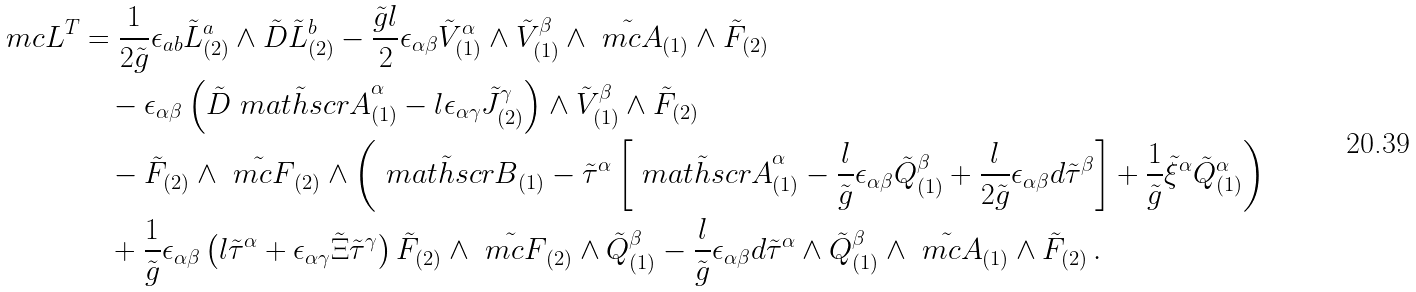Convert formula to latex. <formula><loc_0><loc_0><loc_500><loc_500>\ m c { L } ^ { T } & = \frac { 1 } { 2 \tilde { g } } \epsilon _ { a b } \tilde { L } ^ { a } _ { ( 2 ) } \wedge \tilde { D } \tilde { L } ^ { b } _ { ( 2 ) } - \frac { \tilde { g } l } { 2 } \epsilon _ { \alpha \beta } \tilde { V } ^ { \alpha } _ { ( 1 ) } \wedge \tilde { V } ^ { \beta } _ { ( 1 ) } \wedge \tilde { \ m c { A } } _ { ( 1 ) } \wedge \tilde { F } _ { ( 2 ) } \\ & \quad - \epsilon _ { \alpha \beta } \left ( \tilde { D } \tilde { \ m a t h s c r { A } } ^ { \alpha } _ { ( 1 ) } - l \epsilon _ { \alpha \gamma } \tilde { J } ^ { \gamma } _ { ( 2 ) } \right ) \wedge \tilde { V } ^ { \beta } _ { ( 1 ) } \wedge \tilde { F } _ { ( 2 ) } \\ & \quad - \tilde { F } _ { ( 2 ) } \wedge \tilde { \ m c { F } } _ { ( 2 ) } \wedge \left ( \tilde { \ m a t h s c r { B } } _ { ( 1 ) } - \tilde { \tau } ^ { \alpha } \left [ \tilde { \ m a t h s c r { A } } ^ { \alpha } _ { ( 1 ) } - \frac { l } { \tilde { g } } \epsilon _ { \alpha \beta } \tilde { Q } ^ { \beta } _ { ( 1 ) } + \frac { l } { 2 \tilde { g } } \epsilon _ { \alpha \beta } d \tilde { \tau } ^ { \beta } \right ] + \frac { 1 } { \tilde { g } } \tilde { \xi } ^ { \alpha } \tilde { Q } ^ { \alpha } _ { ( 1 ) } \right ) \\ & \quad + \frac { 1 } { \tilde { g } } \epsilon _ { \alpha \beta } \left ( l \tilde { \tau } ^ { \alpha } + \epsilon _ { \alpha \gamma } \tilde { \Xi } \tilde { \tau } ^ { \gamma } \right ) \tilde { F } _ { ( 2 ) } \wedge \tilde { \ m c { F } } _ { ( 2 ) } \wedge \tilde { Q } ^ { \beta } _ { ( 1 ) } - \frac { l } { \tilde { g } } \epsilon _ { \alpha \beta } d \tilde { \tau } ^ { \alpha } \wedge \tilde { Q } ^ { \beta } _ { ( 1 ) } \wedge \tilde { \ m c { A } } _ { ( 1 ) } \wedge \tilde { F } _ { ( 2 ) } \, .</formula> 